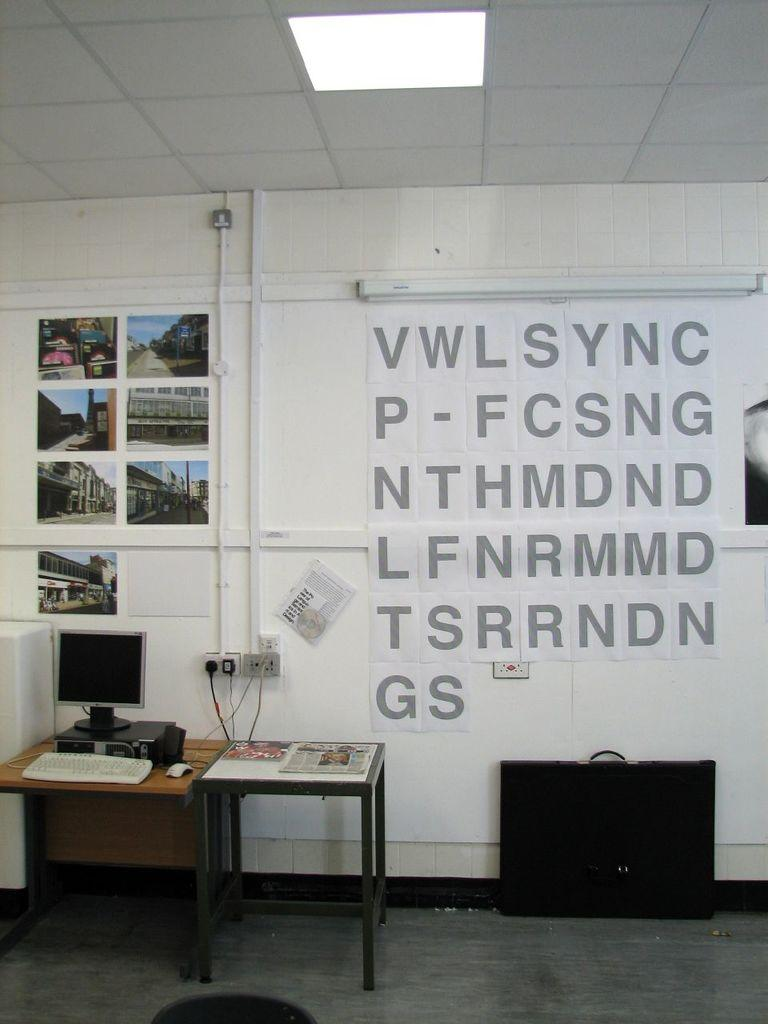What piece of furniture can be seen in the room? There is a desk in the room. What is placed on the desk? There is a system on the desk. What object is on the floor near the desk? There is a black bag on the floor. What is one of the walls in the room used for? Papers are pasted on the wall. What type of leaf is falling from the shirt in the image? There is no leaf or shirt present in the image. 